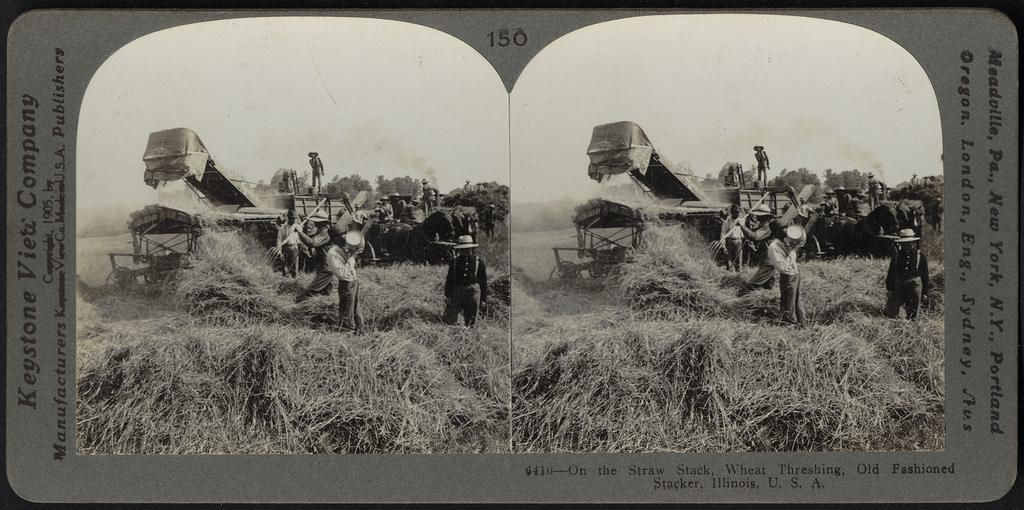<image>
Offer a succinct explanation of the picture presented. An advertisement for Keystone Vieti Company shows trucks working in a field. 